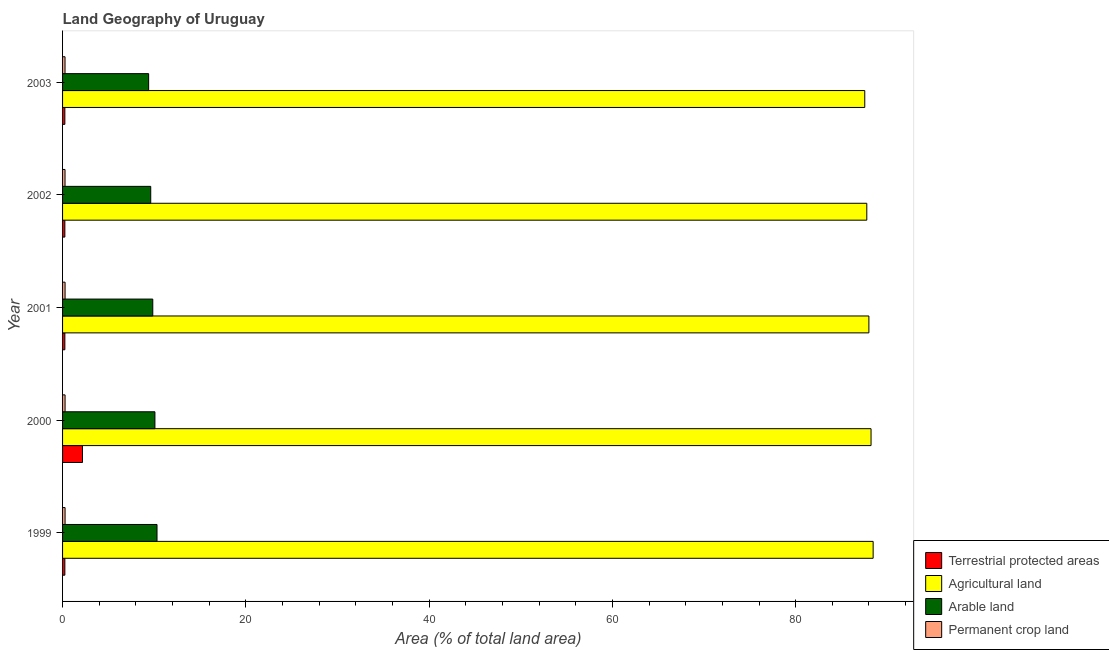How many bars are there on the 1st tick from the top?
Your answer should be very brief. 4. How many bars are there on the 5th tick from the bottom?
Ensure brevity in your answer.  4. In how many cases, is the number of bars for a given year not equal to the number of legend labels?
Make the answer very short. 0. What is the percentage of land under terrestrial protection in 2001?
Give a very brief answer. 0.25. Across all years, what is the maximum percentage of area under agricultural land?
Make the answer very short. 88.45. Across all years, what is the minimum percentage of area under permanent crop land?
Give a very brief answer. 0.27. In which year was the percentage of land under terrestrial protection maximum?
Provide a short and direct response. 2000. What is the total percentage of land under terrestrial protection in the graph?
Provide a succinct answer. 3.18. What is the difference between the percentage of land under terrestrial protection in 2000 and that in 2001?
Your answer should be compact. 1.93. What is the difference between the percentage of area under agricultural land in 2003 and the percentage of area under arable land in 2000?
Provide a short and direct response. 77.46. What is the average percentage of area under arable land per year?
Offer a terse response. 9.85. In the year 2000, what is the difference between the percentage of land under terrestrial protection and percentage of area under agricultural land?
Offer a terse response. -86.05. What is the ratio of the percentage of area under arable land in 1999 to that in 2002?
Your answer should be very brief. 1.07. Is the difference between the percentage of area under agricultural land in 2000 and 2002 greater than the difference between the percentage of area under permanent crop land in 2000 and 2002?
Give a very brief answer. Yes. What is the difference between the highest and the second highest percentage of land under terrestrial protection?
Keep it short and to the point. 1.93. What is the difference between the highest and the lowest percentage of area under agricultural land?
Ensure brevity in your answer.  0.91. Is the sum of the percentage of land under terrestrial protection in 2001 and 2002 greater than the maximum percentage of area under agricultural land across all years?
Your answer should be very brief. No. What does the 4th bar from the top in 2001 represents?
Make the answer very short. Terrestrial protected areas. What does the 2nd bar from the bottom in 2000 represents?
Your answer should be very brief. Agricultural land. Is it the case that in every year, the sum of the percentage of land under terrestrial protection and percentage of area under agricultural land is greater than the percentage of area under arable land?
Your response must be concise. Yes. How many bars are there?
Make the answer very short. 20. Are all the bars in the graph horizontal?
Keep it short and to the point. Yes. How many years are there in the graph?
Keep it short and to the point. 5. What is the difference between two consecutive major ticks on the X-axis?
Make the answer very short. 20. Are the values on the major ticks of X-axis written in scientific E-notation?
Make the answer very short. No. Where does the legend appear in the graph?
Give a very brief answer. Bottom right. How many legend labels are there?
Provide a succinct answer. 4. How are the legend labels stacked?
Provide a short and direct response. Vertical. What is the title of the graph?
Make the answer very short. Land Geography of Uruguay. What is the label or title of the X-axis?
Make the answer very short. Area (% of total land area). What is the label or title of the Y-axis?
Offer a terse response. Year. What is the Area (% of total land area) of Terrestrial protected areas in 1999?
Your answer should be very brief. 0.25. What is the Area (% of total land area) of Agricultural land in 1999?
Your response must be concise. 88.45. What is the Area (% of total land area) in Arable land in 1999?
Give a very brief answer. 10.31. What is the Area (% of total land area) of Permanent crop land in 1999?
Offer a very short reply. 0.27. What is the Area (% of total land area) of Terrestrial protected areas in 2000?
Ensure brevity in your answer.  2.18. What is the Area (% of total land area) of Agricultural land in 2000?
Ensure brevity in your answer.  88.22. What is the Area (% of total land area) in Arable land in 2000?
Ensure brevity in your answer.  10.08. What is the Area (% of total land area) of Permanent crop land in 2000?
Provide a succinct answer. 0.27. What is the Area (% of total land area) in Terrestrial protected areas in 2001?
Keep it short and to the point. 0.25. What is the Area (% of total land area) of Agricultural land in 2001?
Your response must be concise. 87.99. What is the Area (% of total land area) of Arable land in 2001?
Provide a short and direct response. 9.84. What is the Area (% of total land area) in Permanent crop land in 2001?
Make the answer very short. 0.27. What is the Area (% of total land area) of Terrestrial protected areas in 2002?
Give a very brief answer. 0.25. What is the Area (% of total land area) in Agricultural land in 2002?
Provide a succinct answer. 87.76. What is the Area (% of total land area) of Arable land in 2002?
Ensure brevity in your answer.  9.62. What is the Area (% of total land area) in Permanent crop land in 2002?
Offer a very short reply. 0.27. What is the Area (% of total land area) in Terrestrial protected areas in 2003?
Provide a short and direct response. 0.25. What is the Area (% of total land area) in Agricultural land in 2003?
Make the answer very short. 87.54. What is the Area (% of total land area) in Arable land in 2003?
Your answer should be compact. 9.39. What is the Area (% of total land area) in Permanent crop land in 2003?
Your response must be concise. 0.27. Across all years, what is the maximum Area (% of total land area) of Terrestrial protected areas?
Offer a very short reply. 2.18. Across all years, what is the maximum Area (% of total land area) in Agricultural land?
Your answer should be very brief. 88.45. Across all years, what is the maximum Area (% of total land area) of Arable land?
Give a very brief answer. 10.31. Across all years, what is the maximum Area (% of total land area) of Permanent crop land?
Provide a short and direct response. 0.27. Across all years, what is the minimum Area (% of total land area) in Terrestrial protected areas?
Give a very brief answer. 0.25. Across all years, what is the minimum Area (% of total land area) in Agricultural land?
Provide a short and direct response. 87.54. Across all years, what is the minimum Area (% of total land area) in Arable land?
Provide a short and direct response. 9.39. Across all years, what is the minimum Area (% of total land area) in Permanent crop land?
Your answer should be very brief. 0.27. What is the total Area (% of total land area) of Terrestrial protected areas in the graph?
Offer a terse response. 3.18. What is the total Area (% of total land area) in Agricultural land in the graph?
Provide a succinct answer. 439.97. What is the total Area (% of total land area) in Arable land in the graph?
Your answer should be very brief. 49.25. What is the total Area (% of total land area) of Permanent crop land in the graph?
Keep it short and to the point. 1.36. What is the difference between the Area (% of total land area) in Terrestrial protected areas in 1999 and that in 2000?
Keep it short and to the point. -1.92. What is the difference between the Area (% of total land area) of Agricultural land in 1999 and that in 2000?
Ensure brevity in your answer.  0.23. What is the difference between the Area (% of total land area) of Arable land in 1999 and that in 2000?
Give a very brief answer. 0.23. What is the difference between the Area (% of total land area) of Permanent crop land in 1999 and that in 2000?
Ensure brevity in your answer.  0. What is the difference between the Area (% of total land area) in Terrestrial protected areas in 1999 and that in 2001?
Provide a succinct answer. 0. What is the difference between the Area (% of total land area) of Agricultural land in 1999 and that in 2001?
Make the answer very short. 0.46. What is the difference between the Area (% of total land area) of Arable land in 1999 and that in 2001?
Make the answer very short. 0.46. What is the difference between the Area (% of total land area) in Agricultural land in 1999 and that in 2002?
Provide a short and direct response. 0.69. What is the difference between the Area (% of total land area) of Arable land in 1999 and that in 2002?
Provide a succinct answer. 0.69. What is the difference between the Area (% of total land area) in Permanent crop land in 1999 and that in 2002?
Ensure brevity in your answer.  0.01. What is the difference between the Area (% of total land area) in Terrestrial protected areas in 1999 and that in 2003?
Your response must be concise. 0. What is the difference between the Area (% of total land area) of Agricultural land in 1999 and that in 2003?
Offer a terse response. 0.91. What is the difference between the Area (% of total land area) in Arable land in 1999 and that in 2003?
Your answer should be compact. 0.91. What is the difference between the Area (% of total land area) in Permanent crop land in 1999 and that in 2003?
Offer a terse response. 0.01. What is the difference between the Area (% of total land area) of Terrestrial protected areas in 2000 and that in 2001?
Your response must be concise. 1.92. What is the difference between the Area (% of total land area) of Agricultural land in 2000 and that in 2001?
Your response must be concise. 0.23. What is the difference between the Area (% of total land area) of Arable land in 2000 and that in 2001?
Your answer should be very brief. 0.23. What is the difference between the Area (% of total land area) of Permanent crop land in 2000 and that in 2001?
Offer a terse response. 0. What is the difference between the Area (% of total land area) in Terrestrial protected areas in 2000 and that in 2002?
Provide a succinct answer. 1.92. What is the difference between the Area (% of total land area) in Agricultural land in 2000 and that in 2002?
Your response must be concise. 0.46. What is the difference between the Area (% of total land area) of Arable land in 2000 and that in 2002?
Provide a short and direct response. 0.46. What is the difference between the Area (% of total land area) of Permanent crop land in 2000 and that in 2002?
Provide a short and direct response. 0.01. What is the difference between the Area (% of total land area) of Terrestrial protected areas in 2000 and that in 2003?
Give a very brief answer. 1.92. What is the difference between the Area (% of total land area) of Agricultural land in 2000 and that in 2003?
Keep it short and to the point. 0.69. What is the difference between the Area (% of total land area) of Arable land in 2000 and that in 2003?
Offer a terse response. 0.69. What is the difference between the Area (% of total land area) in Permanent crop land in 2000 and that in 2003?
Keep it short and to the point. 0.01. What is the difference between the Area (% of total land area) in Agricultural land in 2001 and that in 2002?
Make the answer very short. 0.23. What is the difference between the Area (% of total land area) of Arable land in 2001 and that in 2002?
Offer a very short reply. 0.22. What is the difference between the Area (% of total land area) of Permanent crop land in 2001 and that in 2002?
Make the answer very short. 0.01. What is the difference between the Area (% of total land area) in Agricultural land in 2001 and that in 2003?
Make the answer very short. 0.45. What is the difference between the Area (% of total land area) in Arable land in 2001 and that in 2003?
Offer a very short reply. 0.45. What is the difference between the Area (% of total land area) in Permanent crop land in 2001 and that in 2003?
Make the answer very short. 0.01. What is the difference between the Area (% of total land area) of Terrestrial protected areas in 2002 and that in 2003?
Ensure brevity in your answer.  0. What is the difference between the Area (% of total land area) in Agricultural land in 2002 and that in 2003?
Make the answer very short. 0.22. What is the difference between the Area (% of total land area) of Arable land in 2002 and that in 2003?
Make the answer very short. 0.23. What is the difference between the Area (% of total land area) of Terrestrial protected areas in 1999 and the Area (% of total land area) of Agricultural land in 2000?
Make the answer very short. -87.97. What is the difference between the Area (% of total land area) in Terrestrial protected areas in 1999 and the Area (% of total land area) in Arable land in 2000?
Provide a short and direct response. -9.83. What is the difference between the Area (% of total land area) in Terrestrial protected areas in 1999 and the Area (% of total land area) in Permanent crop land in 2000?
Ensure brevity in your answer.  -0.02. What is the difference between the Area (% of total land area) of Agricultural land in 1999 and the Area (% of total land area) of Arable land in 2000?
Your answer should be very brief. 78.37. What is the difference between the Area (% of total land area) of Agricultural land in 1999 and the Area (% of total land area) of Permanent crop land in 2000?
Make the answer very short. 88.18. What is the difference between the Area (% of total land area) of Arable land in 1999 and the Area (% of total land area) of Permanent crop land in 2000?
Your answer should be very brief. 10.03. What is the difference between the Area (% of total land area) in Terrestrial protected areas in 1999 and the Area (% of total land area) in Agricultural land in 2001?
Your response must be concise. -87.74. What is the difference between the Area (% of total land area) in Terrestrial protected areas in 1999 and the Area (% of total land area) in Arable land in 2001?
Provide a short and direct response. -9.59. What is the difference between the Area (% of total land area) of Terrestrial protected areas in 1999 and the Area (% of total land area) of Permanent crop land in 2001?
Ensure brevity in your answer.  -0.02. What is the difference between the Area (% of total land area) of Agricultural land in 1999 and the Area (% of total land area) of Arable land in 2001?
Your response must be concise. 78.61. What is the difference between the Area (% of total land area) in Agricultural land in 1999 and the Area (% of total land area) in Permanent crop land in 2001?
Make the answer very short. 88.18. What is the difference between the Area (% of total land area) in Arable land in 1999 and the Area (% of total land area) in Permanent crop land in 2001?
Your answer should be compact. 10.03. What is the difference between the Area (% of total land area) of Terrestrial protected areas in 1999 and the Area (% of total land area) of Agricultural land in 2002?
Give a very brief answer. -87.51. What is the difference between the Area (% of total land area) in Terrestrial protected areas in 1999 and the Area (% of total land area) in Arable land in 2002?
Provide a short and direct response. -9.37. What is the difference between the Area (% of total land area) in Terrestrial protected areas in 1999 and the Area (% of total land area) in Permanent crop land in 2002?
Offer a terse response. -0.02. What is the difference between the Area (% of total land area) of Agricultural land in 1999 and the Area (% of total land area) of Arable land in 2002?
Your answer should be very brief. 78.83. What is the difference between the Area (% of total land area) in Agricultural land in 1999 and the Area (% of total land area) in Permanent crop land in 2002?
Provide a short and direct response. 88.18. What is the difference between the Area (% of total land area) of Arable land in 1999 and the Area (% of total land area) of Permanent crop land in 2002?
Offer a very short reply. 10.04. What is the difference between the Area (% of total land area) of Terrestrial protected areas in 1999 and the Area (% of total land area) of Agricultural land in 2003?
Your answer should be compact. -87.29. What is the difference between the Area (% of total land area) in Terrestrial protected areas in 1999 and the Area (% of total land area) in Arable land in 2003?
Give a very brief answer. -9.14. What is the difference between the Area (% of total land area) in Terrestrial protected areas in 1999 and the Area (% of total land area) in Permanent crop land in 2003?
Your response must be concise. -0.02. What is the difference between the Area (% of total land area) of Agricultural land in 1999 and the Area (% of total land area) of Arable land in 2003?
Provide a short and direct response. 79.06. What is the difference between the Area (% of total land area) of Agricultural land in 1999 and the Area (% of total land area) of Permanent crop land in 2003?
Offer a terse response. 88.18. What is the difference between the Area (% of total land area) in Arable land in 1999 and the Area (% of total land area) in Permanent crop land in 2003?
Provide a succinct answer. 10.04. What is the difference between the Area (% of total land area) in Terrestrial protected areas in 2000 and the Area (% of total land area) in Agricultural land in 2001?
Your response must be concise. -85.81. What is the difference between the Area (% of total land area) of Terrestrial protected areas in 2000 and the Area (% of total land area) of Arable land in 2001?
Your answer should be compact. -7.67. What is the difference between the Area (% of total land area) of Terrestrial protected areas in 2000 and the Area (% of total land area) of Permanent crop land in 2001?
Your response must be concise. 1.9. What is the difference between the Area (% of total land area) in Agricultural land in 2000 and the Area (% of total land area) in Arable land in 2001?
Your answer should be compact. 78.38. What is the difference between the Area (% of total land area) of Agricultural land in 2000 and the Area (% of total land area) of Permanent crop land in 2001?
Give a very brief answer. 87.95. What is the difference between the Area (% of total land area) in Arable land in 2000 and the Area (% of total land area) in Permanent crop land in 2001?
Your answer should be very brief. 9.8. What is the difference between the Area (% of total land area) in Terrestrial protected areas in 2000 and the Area (% of total land area) in Agricultural land in 2002?
Provide a short and direct response. -85.59. What is the difference between the Area (% of total land area) in Terrestrial protected areas in 2000 and the Area (% of total land area) in Arable land in 2002?
Keep it short and to the point. -7.45. What is the difference between the Area (% of total land area) of Terrestrial protected areas in 2000 and the Area (% of total land area) of Permanent crop land in 2002?
Give a very brief answer. 1.91. What is the difference between the Area (% of total land area) in Agricultural land in 2000 and the Area (% of total land area) in Arable land in 2002?
Provide a succinct answer. 78.6. What is the difference between the Area (% of total land area) in Agricultural land in 2000 and the Area (% of total land area) in Permanent crop land in 2002?
Provide a succinct answer. 87.96. What is the difference between the Area (% of total land area) in Arable land in 2000 and the Area (% of total land area) in Permanent crop land in 2002?
Offer a terse response. 9.81. What is the difference between the Area (% of total land area) of Terrestrial protected areas in 2000 and the Area (% of total land area) of Agricultural land in 2003?
Keep it short and to the point. -85.36. What is the difference between the Area (% of total land area) of Terrestrial protected areas in 2000 and the Area (% of total land area) of Arable land in 2003?
Make the answer very short. -7.22. What is the difference between the Area (% of total land area) in Terrestrial protected areas in 2000 and the Area (% of total land area) in Permanent crop land in 2003?
Your response must be concise. 1.91. What is the difference between the Area (% of total land area) of Agricultural land in 2000 and the Area (% of total land area) of Arable land in 2003?
Your answer should be compact. 78.83. What is the difference between the Area (% of total land area) in Agricultural land in 2000 and the Area (% of total land area) in Permanent crop land in 2003?
Provide a short and direct response. 87.96. What is the difference between the Area (% of total land area) of Arable land in 2000 and the Area (% of total land area) of Permanent crop land in 2003?
Provide a short and direct response. 9.81. What is the difference between the Area (% of total land area) of Terrestrial protected areas in 2001 and the Area (% of total land area) of Agricultural land in 2002?
Your answer should be compact. -87.51. What is the difference between the Area (% of total land area) in Terrestrial protected areas in 2001 and the Area (% of total land area) in Arable land in 2002?
Ensure brevity in your answer.  -9.37. What is the difference between the Area (% of total land area) in Terrestrial protected areas in 2001 and the Area (% of total land area) in Permanent crop land in 2002?
Your answer should be very brief. -0.02. What is the difference between the Area (% of total land area) of Agricultural land in 2001 and the Area (% of total land area) of Arable land in 2002?
Provide a succinct answer. 78.37. What is the difference between the Area (% of total land area) of Agricultural land in 2001 and the Area (% of total land area) of Permanent crop land in 2002?
Ensure brevity in your answer.  87.72. What is the difference between the Area (% of total land area) in Arable land in 2001 and the Area (% of total land area) in Permanent crop land in 2002?
Provide a succinct answer. 9.58. What is the difference between the Area (% of total land area) of Terrestrial protected areas in 2001 and the Area (% of total land area) of Agricultural land in 2003?
Make the answer very short. -87.29. What is the difference between the Area (% of total land area) of Terrestrial protected areas in 2001 and the Area (% of total land area) of Arable land in 2003?
Provide a succinct answer. -9.14. What is the difference between the Area (% of total land area) of Terrestrial protected areas in 2001 and the Area (% of total land area) of Permanent crop land in 2003?
Offer a terse response. -0.02. What is the difference between the Area (% of total land area) in Agricultural land in 2001 and the Area (% of total land area) in Arable land in 2003?
Your answer should be compact. 78.6. What is the difference between the Area (% of total land area) of Agricultural land in 2001 and the Area (% of total land area) of Permanent crop land in 2003?
Provide a short and direct response. 87.72. What is the difference between the Area (% of total land area) of Arable land in 2001 and the Area (% of total land area) of Permanent crop land in 2003?
Offer a very short reply. 9.58. What is the difference between the Area (% of total land area) in Terrestrial protected areas in 2002 and the Area (% of total land area) in Agricultural land in 2003?
Your answer should be very brief. -87.29. What is the difference between the Area (% of total land area) of Terrestrial protected areas in 2002 and the Area (% of total land area) of Arable land in 2003?
Your response must be concise. -9.14. What is the difference between the Area (% of total land area) in Terrestrial protected areas in 2002 and the Area (% of total land area) in Permanent crop land in 2003?
Give a very brief answer. -0.02. What is the difference between the Area (% of total land area) of Agricultural land in 2002 and the Area (% of total land area) of Arable land in 2003?
Your answer should be compact. 78.37. What is the difference between the Area (% of total land area) in Agricultural land in 2002 and the Area (% of total land area) in Permanent crop land in 2003?
Offer a very short reply. 87.49. What is the difference between the Area (% of total land area) of Arable land in 2002 and the Area (% of total land area) of Permanent crop land in 2003?
Provide a short and direct response. 9.35. What is the average Area (% of total land area) in Terrestrial protected areas per year?
Keep it short and to the point. 0.64. What is the average Area (% of total land area) in Agricultural land per year?
Your response must be concise. 87.99. What is the average Area (% of total land area) in Arable land per year?
Ensure brevity in your answer.  9.85. What is the average Area (% of total land area) in Permanent crop land per year?
Offer a very short reply. 0.27. In the year 1999, what is the difference between the Area (% of total land area) of Terrestrial protected areas and Area (% of total land area) of Agricultural land?
Offer a very short reply. -88.2. In the year 1999, what is the difference between the Area (% of total land area) of Terrestrial protected areas and Area (% of total land area) of Arable land?
Provide a short and direct response. -10.06. In the year 1999, what is the difference between the Area (% of total land area) of Terrestrial protected areas and Area (% of total land area) of Permanent crop land?
Offer a terse response. -0.02. In the year 1999, what is the difference between the Area (% of total land area) of Agricultural land and Area (% of total land area) of Arable land?
Your response must be concise. 78.15. In the year 1999, what is the difference between the Area (% of total land area) in Agricultural land and Area (% of total land area) in Permanent crop land?
Provide a succinct answer. 88.18. In the year 1999, what is the difference between the Area (% of total land area) of Arable land and Area (% of total land area) of Permanent crop land?
Your response must be concise. 10.03. In the year 2000, what is the difference between the Area (% of total land area) of Terrestrial protected areas and Area (% of total land area) of Agricultural land?
Offer a very short reply. -86.05. In the year 2000, what is the difference between the Area (% of total land area) in Terrestrial protected areas and Area (% of total land area) in Arable land?
Make the answer very short. -7.9. In the year 2000, what is the difference between the Area (% of total land area) in Terrestrial protected areas and Area (% of total land area) in Permanent crop land?
Give a very brief answer. 1.9. In the year 2000, what is the difference between the Area (% of total land area) of Agricultural land and Area (% of total land area) of Arable land?
Give a very brief answer. 78.15. In the year 2000, what is the difference between the Area (% of total land area) of Agricultural land and Area (% of total land area) of Permanent crop land?
Provide a succinct answer. 87.95. In the year 2000, what is the difference between the Area (% of total land area) of Arable land and Area (% of total land area) of Permanent crop land?
Ensure brevity in your answer.  9.8. In the year 2001, what is the difference between the Area (% of total land area) in Terrestrial protected areas and Area (% of total land area) in Agricultural land?
Provide a succinct answer. -87.74. In the year 2001, what is the difference between the Area (% of total land area) of Terrestrial protected areas and Area (% of total land area) of Arable land?
Your response must be concise. -9.59. In the year 2001, what is the difference between the Area (% of total land area) of Terrestrial protected areas and Area (% of total land area) of Permanent crop land?
Ensure brevity in your answer.  -0.02. In the year 2001, what is the difference between the Area (% of total land area) in Agricultural land and Area (% of total land area) in Arable land?
Your answer should be very brief. 78.15. In the year 2001, what is the difference between the Area (% of total land area) of Agricultural land and Area (% of total land area) of Permanent crop land?
Your answer should be compact. 87.72. In the year 2001, what is the difference between the Area (% of total land area) of Arable land and Area (% of total land area) of Permanent crop land?
Keep it short and to the point. 9.57. In the year 2002, what is the difference between the Area (% of total land area) of Terrestrial protected areas and Area (% of total land area) of Agricultural land?
Keep it short and to the point. -87.51. In the year 2002, what is the difference between the Area (% of total land area) of Terrestrial protected areas and Area (% of total land area) of Arable land?
Offer a terse response. -9.37. In the year 2002, what is the difference between the Area (% of total land area) in Terrestrial protected areas and Area (% of total land area) in Permanent crop land?
Your answer should be very brief. -0.02. In the year 2002, what is the difference between the Area (% of total land area) in Agricultural land and Area (% of total land area) in Arable land?
Ensure brevity in your answer.  78.14. In the year 2002, what is the difference between the Area (% of total land area) in Agricultural land and Area (% of total land area) in Permanent crop land?
Offer a very short reply. 87.49. In the year 2002, what is the difference between the Area (% of total land area) in Arable land and Area (% of total land area) in Permanent crop land?
Your answer should be compact. 9.35. In the year 2003, what is the difference between the Area (% of total land area) of Terrestrial protected areas and Area (% of total land area) of Agricultural land?
Make the answer very short. -87.29. In the year 2003, what is the difference between the Area (% of total land area) of Terrestrial protected areas and Area (% of total land area) of Arable land?
Provide a succinct answer. -9.14. In the year 2003, what is the difference between the Area (% of total land area) in Terrestrial protected areas and Area (% of total land area) in Permanent crop land?
Give a very brief answer. -0.02. In the year 2003, what is the difference between the Area (% of total land area) of Agricultural land and Area (% of total land area) of Arable land?
Your answer should be very brief. 78.15. In the year 2003, what is the difference between the Area (% of total land area) in Agricultural land and Area (% of total land area) in Permanent crop land?
Offer a terse response. 87.27. In the year 2003, what is the difference between the Area (% of total land area) in Arable land and Area (% of total land area) in Permanent crop land?
Your response must be concise. 9.12. What is the ratio of the Area (% of total land area) of Terrestrial protected areas in 1999 to that in 2000?
Your response must be concise. 0.12. What is the ratio of the Area (% of total land area) of Arable land in 1999 to that in 2000?
Make the answer very short. 1.02. What is the ratio of the Area (% of total land area) of Permanent crop land in 1999 to that in 2000?
Provide a succinct answer. 1. What is the ratio of the Area (% of total land area) of Terrestrial protected areas in 1999 to that in 2001?
Provide a short and direct response. 1. What is the ratio of the Area (% of total land area) of Arable land in 1999 to that in 2001?
Provide a succinct answer. 1.05. What is the ratio of the Area (% of total land area) in Permanent crop land in 1999 to that in 2001?
Your answer should be compact. 1. What is the ratio of the Area (% of total land area) of Agricultural land in 1999 to that in 2002?
Your answer should be compact. 1.01. What is the ratio of the Area (% of total land area) in Arable land in 1999 to that in 2002?
Give a very brief answer. 1.07. What is the ratio of the Area (% of total land area) of Permanent crop land in 1999 to that in 2002?
Make the answer very short. 1.02. What is the ratio of the Area (% of total land area) in Agricultural land in 1999 to that in 2003?
Offer a very short reply. 1.01. What is the ratio of the Area (% of total land area) in Arable land in 1999 to that in 2003?
Keep it short and to the point. 1.1. What is the ratio of the Area (% of total land area) of Permanent crop land in 1999 to that in 2003?
Offer a very short reply. 1.02. What is the ratio of the Area (% of total land area) in Terrestrial protected areas in 2000 to that in 2001?
Provide a succinct answer. 8.67. What is the ratio of the Area (% of total land area) of Agricultural land in 2000 to that in 2001?
Give a very brief answer. 1. What is the ratio of the Area (% of total land area) of Arable land in 2000 to that in 2001?
Offer a very short reply. 1.02. What is the ratio of the Area (% of total land area) in Terrestrial protected areas in 2000 to that in 2002?
Your answer should be compact. 8.67. What is the ratio of the Area (% of total land area) in Agricultural land in 2000 to that in 2002?
Keep it short and to the point. 1.01. What is the ratio of the Area (% of total land area) in Arable land in 2000 to that in 2002?
Offer a very short reply. 1.05. What is the ratio of the Area (% of total land area) in Permanent crop land in 2000 to that in 2002?
Give a very brief answer. 1.02. What is the ratio of the Area (% of total land area) in Terrestrial protected areas in 2000 to that in 2003?
Provide a short and direct response. 8.67. What is the ratio of the Area (% of total land area) in Arable land in 2000 to that in 2003?
Provide a short and direct response. 1.07. What is the ratio of the Area (% of total land area) of Permanent crop land in 2000 to that in 2003?
Provide a succinct answer. 1.02. What is the ratio of the Area (% of total land area) in Arable land in 2001 to that in 2002?
Offer a terse response. 1.02. What is the ratio of the Area (% of total land area) in Permanent crop land in 2001 to that in 2002?
Provide a succinct answer. 1.02. What is the ratio of the Area (% of total land area) of Arable land in 2001 to that in 2003?
Your answer should be very brief. 1.05. What is the ratio of the Area (% of total land area) in Permanent crop land in 2001 to that in 2003?
Give a very brief answer. 1.02. What is the ratio of the Area (% of total land area) in Agricultural land in 2002 to that in 2003?
Offer a terse response. 1. What is the ratio of the Area (% of total land area) in Arable land in 2002 to that in 2003?
Keep it short and to the point. 1.02. What is the ratio of the Area (% of total land area) in Permanent crop land in 2002 to that in 2003?
Keep it short and to the point. 1. What is the difference between the highest and the second highest Area (% of total land area) in Terrestrial protected areas?
Your response must be concise. 1.92. What is the difference between the highest and the second highest Area (% of total land area) in Agricultural land?
Make the answer very short. 0.23. What is the difference between the highest and the second highest Area (% of total land area) of Arable land?
Your answer should be very brief. 0.23. What is the difference between the highest and the second highest Area (% of total land area) in Permanent crop land?
Your response must be concise. 0. What is the difference between the highest and the lowest Area (% of total land area) in Terrestrial protected areas?
Provide a succinct answer. 1.92. What is the difference between the highest and the lowest Area (% of total land area) of Agricultural land?
Offer a very short reply. 0.91. What is the difference between the highest and the lowest Area (% of total land area) in Arable land?
Your answer should be compact. 0.91. What is the difference between the highest and the lowest Area (% of total land area) in Permanent crop land?
Your answer should be very brief. 0.01. 